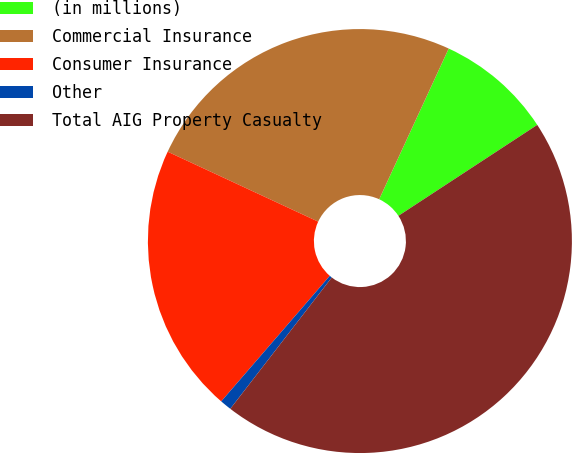<chart> <loc_0><loc_0><loc_500><loc_500><pie_chart><fcel>(in millions)<fcel>Commercial Insurance<fcel>Consumer Insurance<fcel>Other<fcel>Total AIG Property Casualty<nl><fcel>8.89%<fcel>24.95%<fcel>20.57%<fcel>0.88%<fcel>44.69%<nl></chart> 